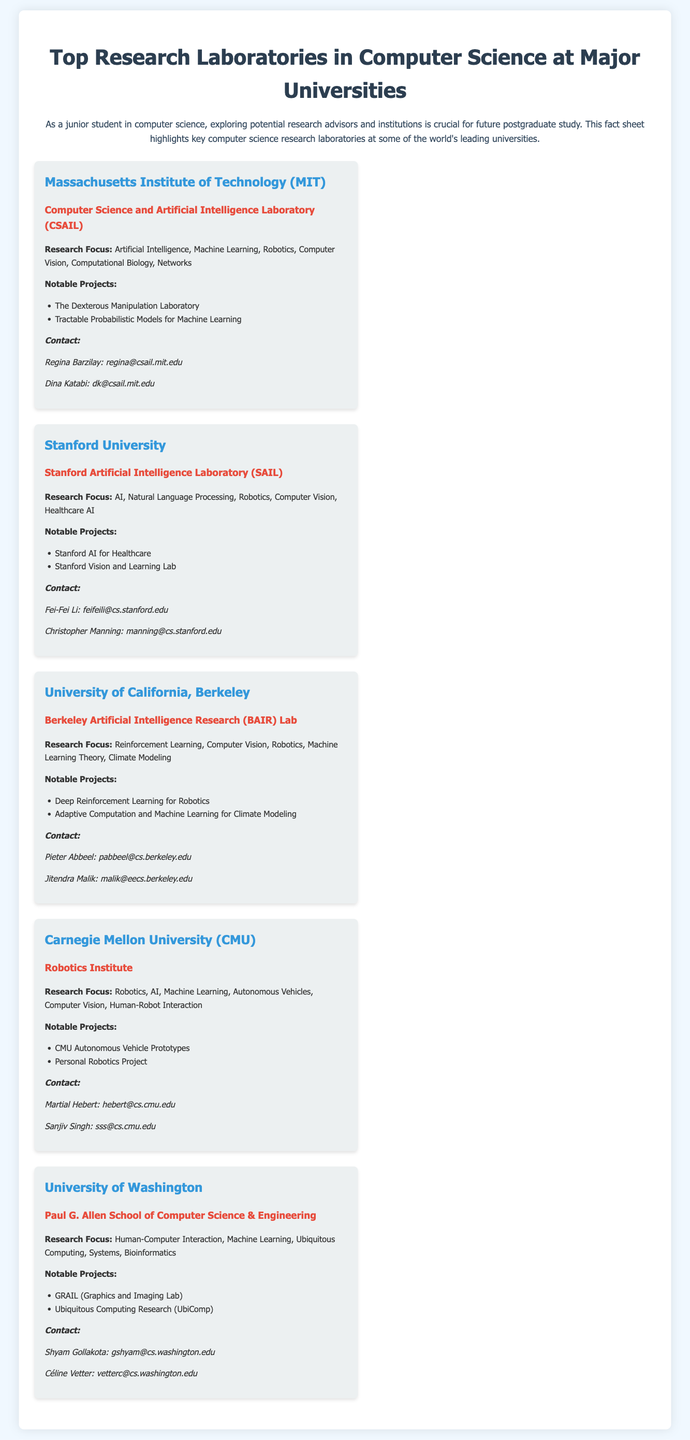what is the name of the laboratory at MIT? The name of the laboratory at MIT is the Computer Science and Artificial Intelligence Laboratory (CSAIL).
Answer: Computer Science and Artificial Intelligence Laboratory (CSAIL) who is a contact person at Stanford University? One of the contact persons at Stanford University is Fei-Fei Li.
Answer: Fei-Fei Li what is the research focus of the Berkeley Artificial Intelligence Research (BAIR) Lab? The research focus of the BAIR Lab includes Reinforcement Learning, Computer Vision, Robotics, Machine Learning Theory, and Climate Modeling.
Answer: Reinforcement Learning, Computer Vision, Robotics, Machine Learning Theory, Climate Modeling how many notable projects are listed for the Carnegie Mellon University Robotics Institute? The Robotics Institute at Carnegie Mellon University has two notable projects listed.
Answer: 2 which university is associated with the GRAIL project? The GRAIL project is associated with the University of Washington.
Answer: University of Washington what type of research focus does the Paul G. Allen School emphasize? The Paul G. Allen School focuses on Human-Computer Interaction, Machine Learning, Ubiquitous Computing, Systems, and Bioinformatics.
Answer: Human-Computer Interaction, Machine Learning, Ubiquitous Computing, Systems, Bioinformatics who is a contact person at the University of California, Berkeley? One of the contact persons at the University of California, Berkeley is Pieter Abbeel.
Answer: Pieter Abbeel what notable project is mentioned for Stanford University? One notable project mentioned for Stanford University is Stanford AI for Healthcare.
Answer: Stanford AI for Healthcare 